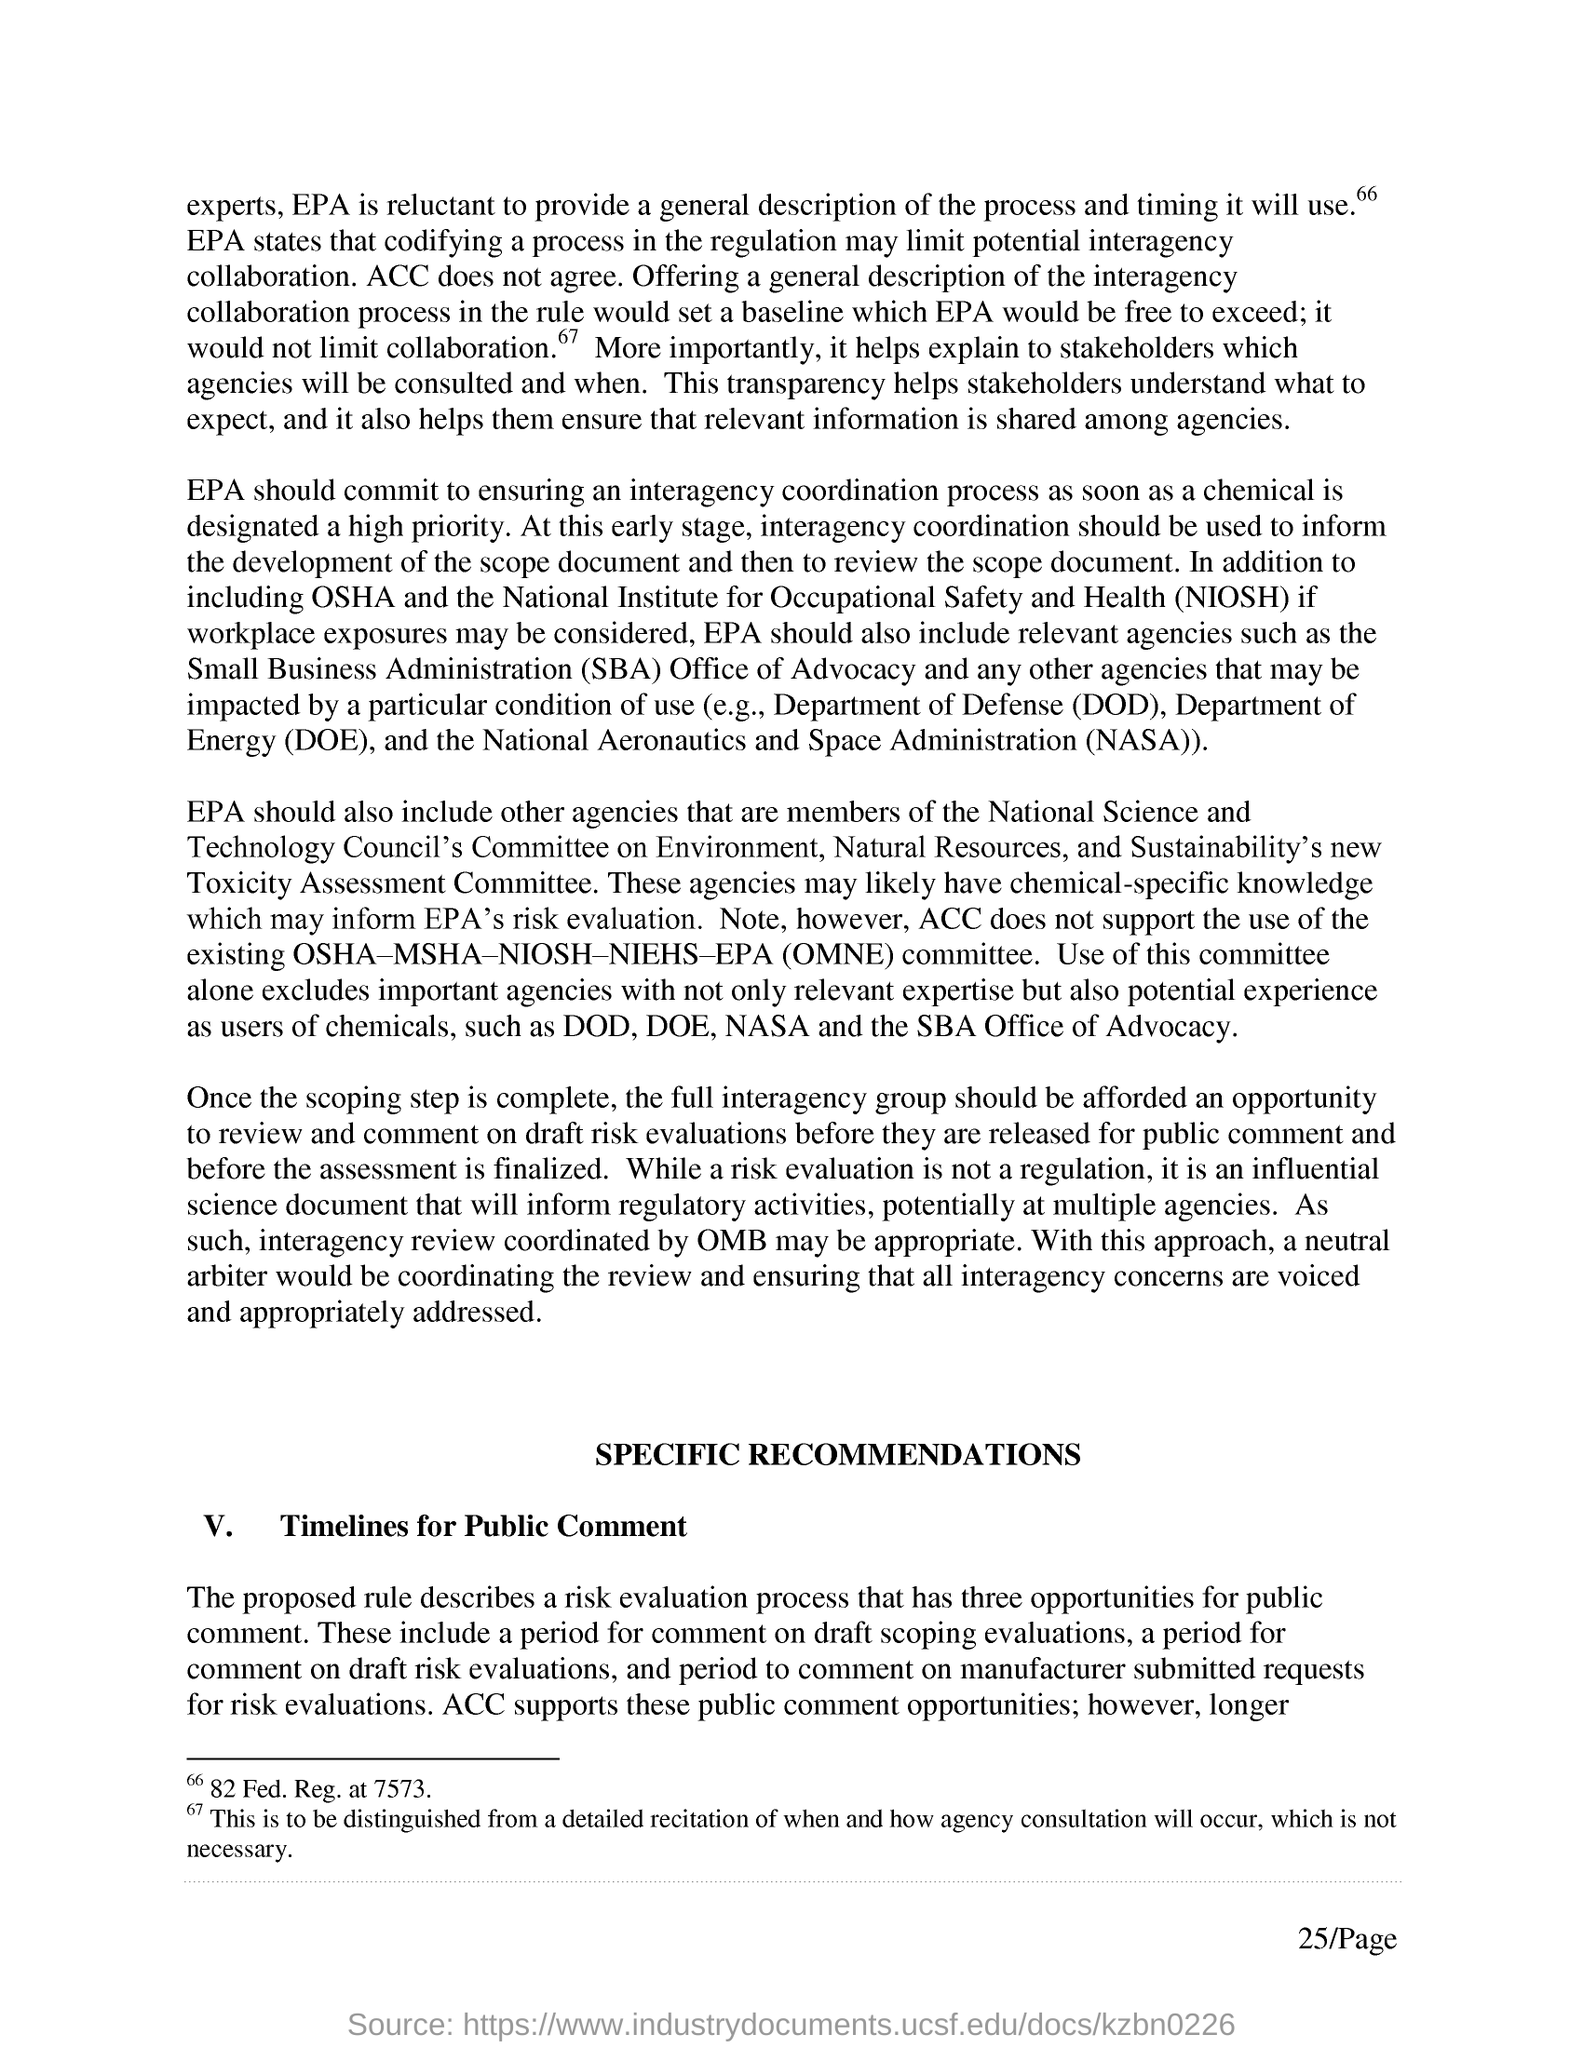Point out several critical features in this image. The Small Business Administration (SBA) is a U.S. government agency that provides support and assistance to small businesses. The Department of Defense (DOD) is a government agency responsible for the military functions of the United States. 